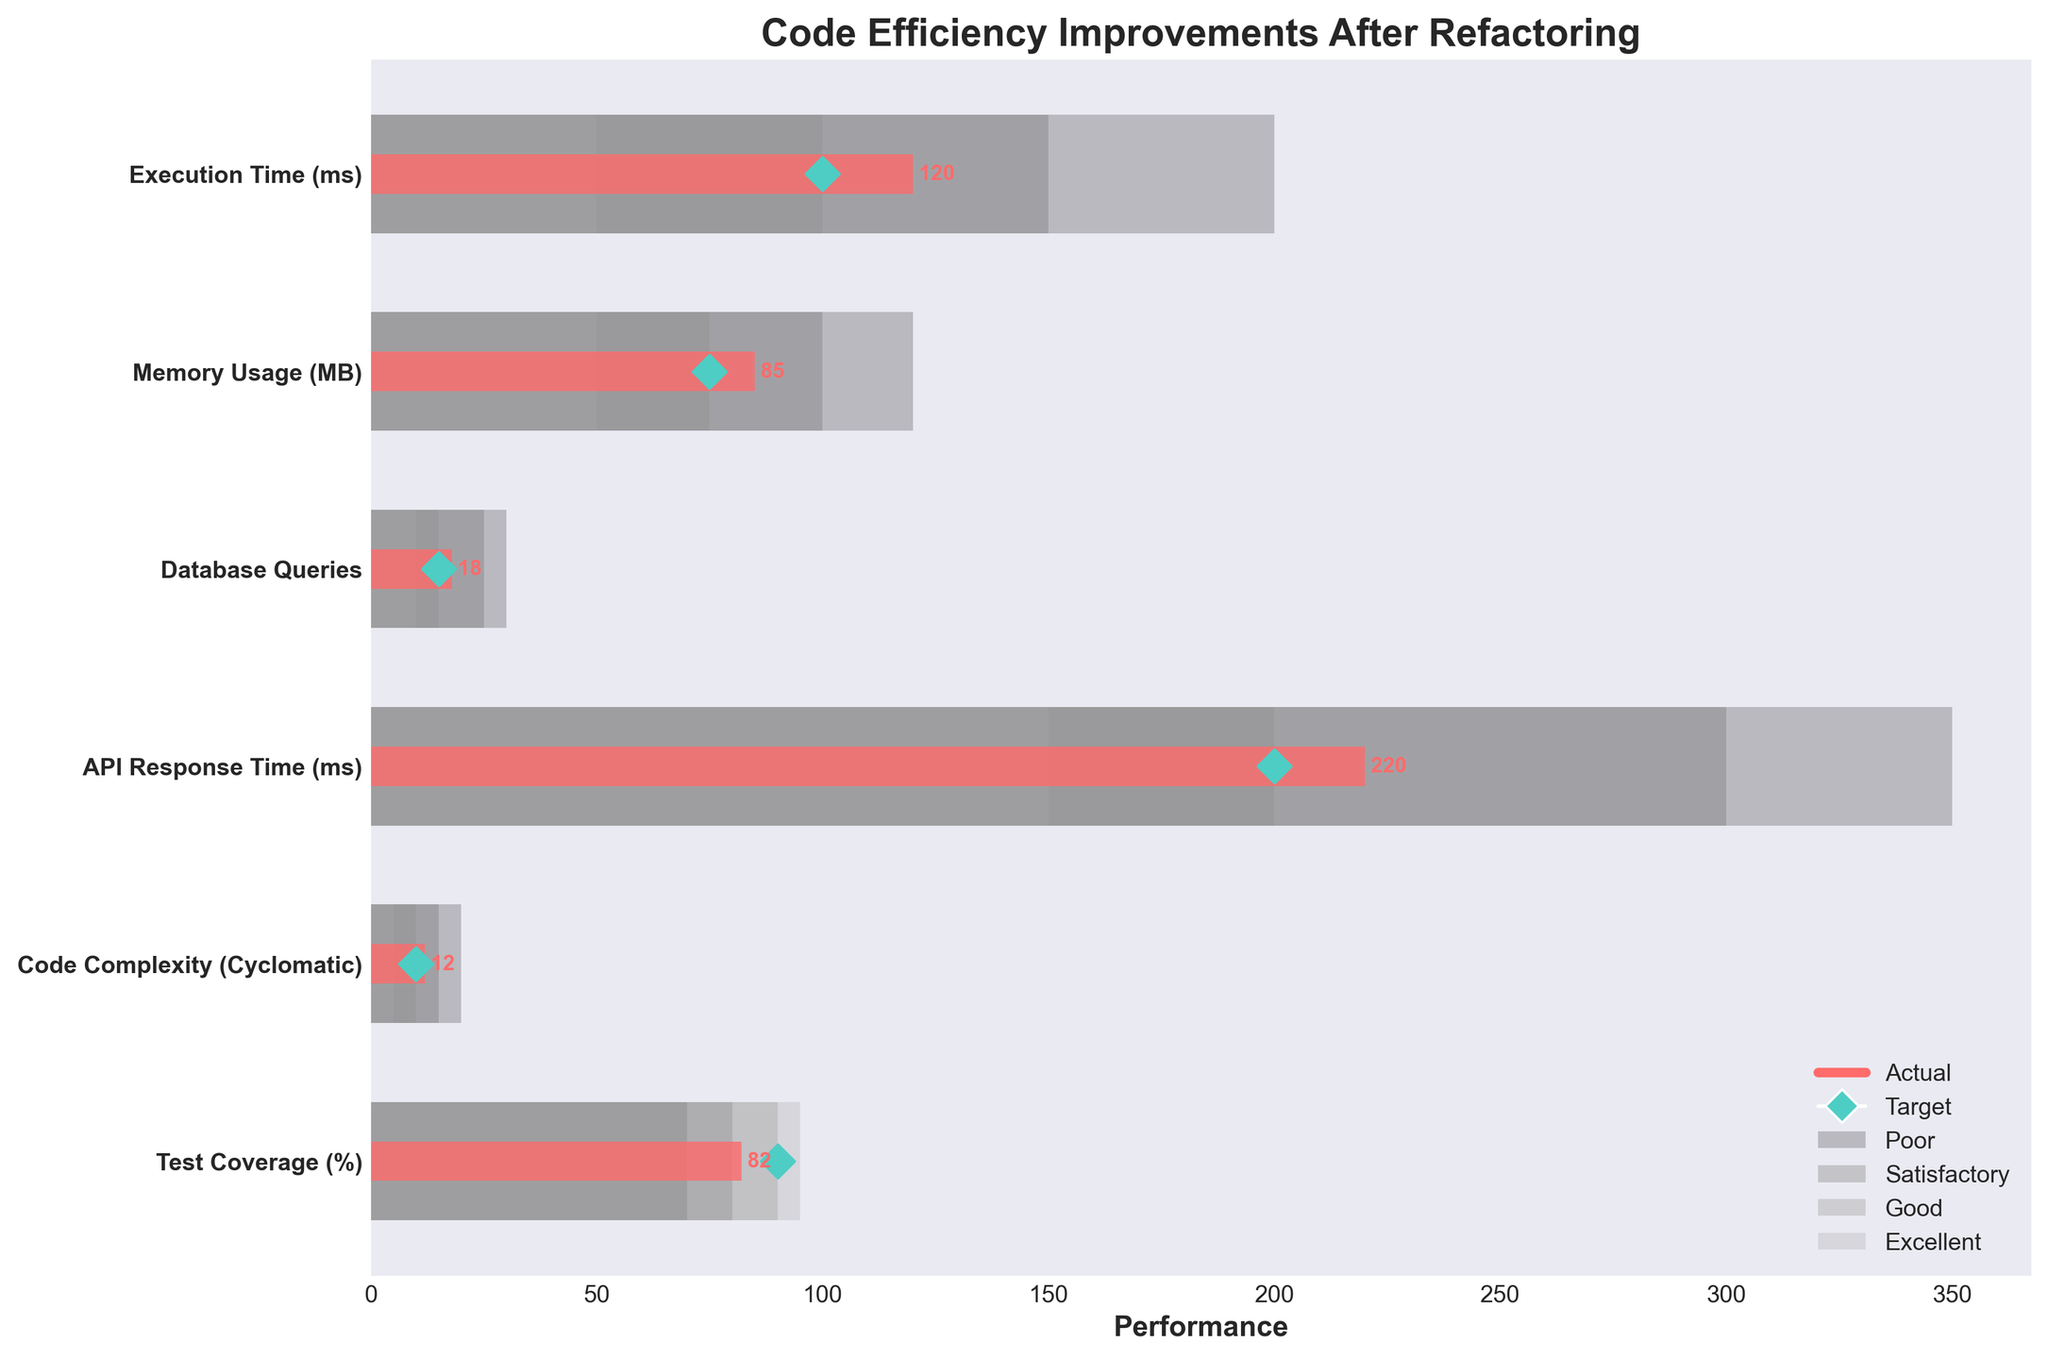What's the title of the chart? The title is located at the top of the chart and is usually a brief description of what the chart represents.
Answer: Code Efficiency Improvements After Refactoring How many performance metrics are displayed in the chart? Count the number of unique metrics listed on the y-axis of the chart.
Answer: 6 What color represents the 'Excellent' performance range? The color can be identified by looking at the legend that matches the 'Excellent' label to its color.
Answer: Light gray What is the target value for Test Coverage? Locate the target marker for the Test Coverage metric and read its value.
Answer: 90 Is the actual API Response Time above or below the target? Compare the position of the actual bar with the target marker for the API Response Time metric.
Answer: Above What is the difference between the actual and target values for Execution Time? Subtract the target value from the actual value for Execution Time (120 ms - 100 ms).
Answer: 20 ms Which metric shows the greatest deviation from its target value? Compare the absolute differences between actual and target values for all metrics and identify the largest difference.
Answer: API Response Time For Code Complexity, is the actual performance in the good or poor range? Locate the actual bar for Code Complexity and see if it falls within the good or poor performance range based on the background segments.
Answer: Good Which metric has the smallest difference between actual and target values? Calculate the differences between actual and target values for all metrics and identify the smallest difference.
Answer: Memory Usage Are any metrics meeting their 'Excellent' performance criteria? Check if any actual bars fall within the 'Excellent' performance range for any metrics.
Answer: No 